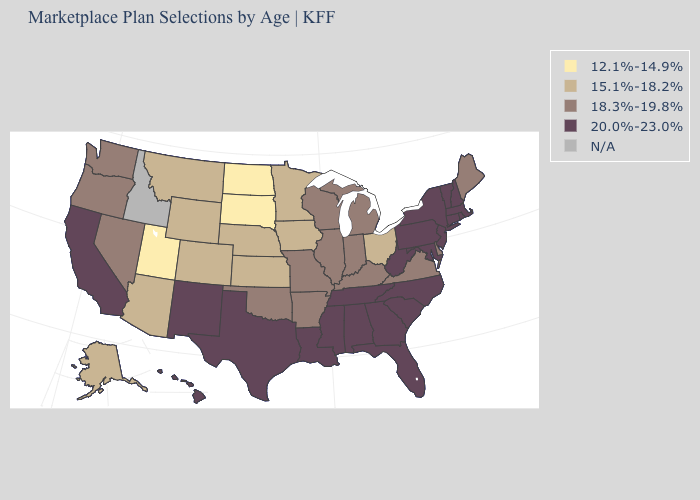Does Kansas have the lowest value in the MidWest?
Be succinct. No. What is the value of Wisconsin?
Answer briefly. 18.3%-19.8%. Among the states that border New Jersey , does Delaware have the highest value?
Quick response, please. No. What is the value of Ohio?
Concise answer only. 15.1%-18.2%. What is the value of Kentucky?
Short answer required. 18.3%-19.8%. What is the highest value in the West ?
Answer briefly. 20.0%-23.0%. Does Oregon have the highest value in the West?
Quick response, please. No. What is the value of Idaho?
Concise answer only. N/A. What is the lowest value in states that border Maryland?
Quick response, please. 18.3%-19.8%. What is the value of Tennessee?
Short answer required. 20.0%-23.0%. Name the states that have a value in the range 12.1%-14.9%?
Concise answer only. North Dakota, South Dakota, Utah. How many symbols are there in the legend?
Answer briefly. 5. What is the lowest value in states that border Massachusetts?
Short answer required. 20.0%-23.0%. What is the value of North Carolina?
Answer briefly. 20.0%-23.0%. 